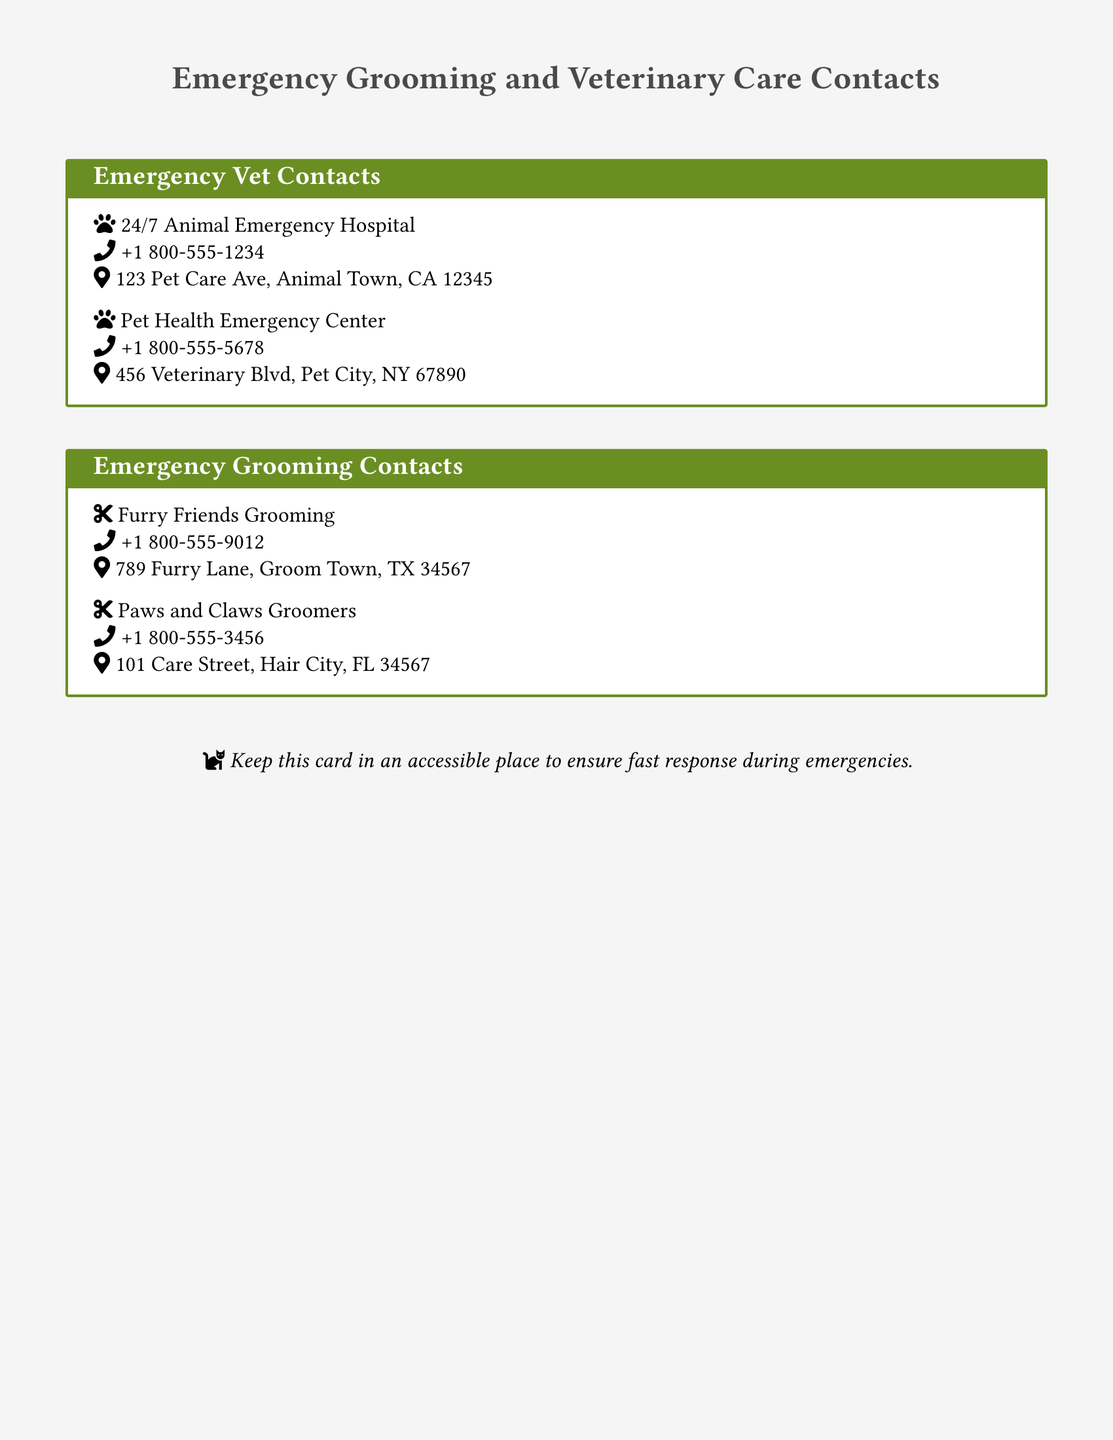What is the phone number for the 24/7 Animal Emergency Hospital? The phone number for this emergency hospital is the one listed directly under its name.
Answer: +1 800-555-1234 How many emergency veterinarian contacts are listed? The document contains information about two emergency veterinarian contacts.
Answer: 2 What is the address of Furry Friends Grooming? This address can be found under the contact details for this grooming service.
Answer: 789 Furry Lane, Groom Town, TX 34567 Which icon represents the grooming services? The icon that represents grooming is indicated by a specific symbol next to the grooming service names.
Answer: Cut What is the purpose of keeping this card accessible? The document states a specific recommendation regarding the card's accessibility during emergencies.
Answer: Ensures fast response during emergencies 